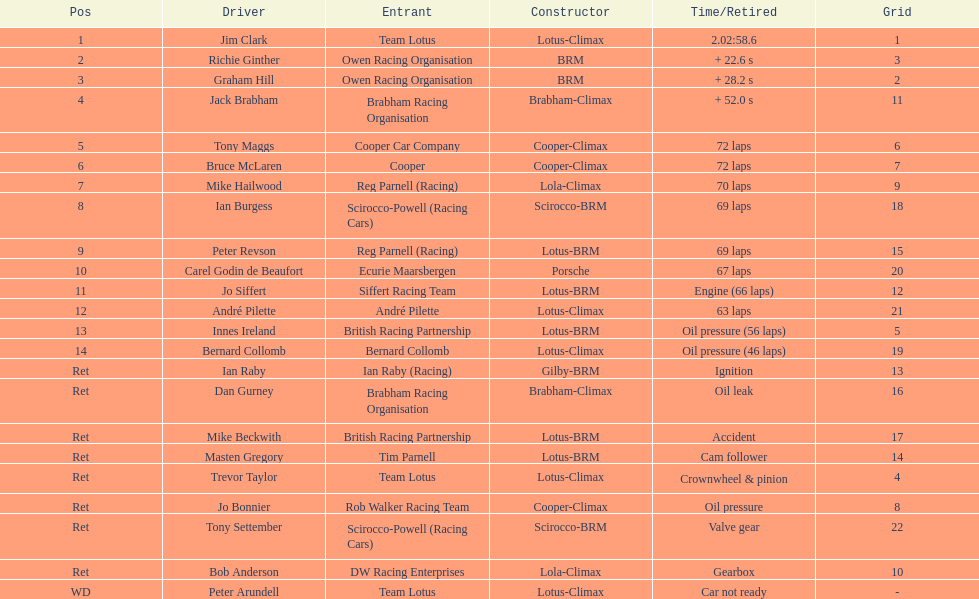Who was the top finisher that drove a cooper-climax? Tony Maggs. 